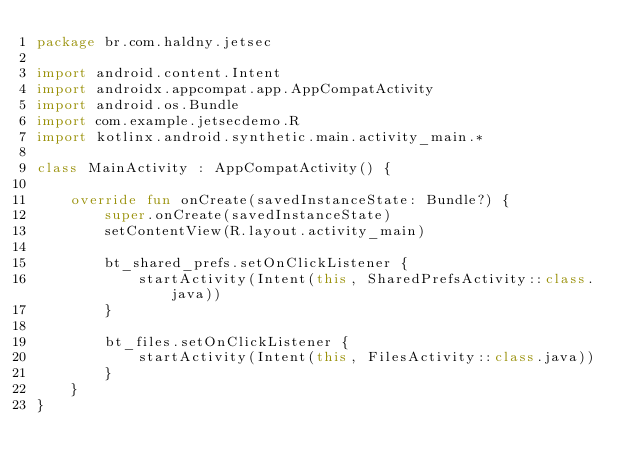Convert code to text. <code><loc_0><loc_0><loc_500><loc_500><_Kotlin_>package br.com.haldny.jetsec

import android.content.Intent
import androidx.appcompat.app.AppCompatActivity
import android.os.Bundle
import com.example.jetsecdemo.R
import kotlinx.android.synthetic.main.activity_main.*

class MainActivity : AppCompatActivity() {

    override fun onCreate(savedInstanceState: Bundle?) {
        super.onCreate(savedInstanceState)
        setContentView(R.layout.activity_main)

        bt_shared_prefs.setOnClickListener {
            startActivity(Intent(this, SharedPrefsActivity::class.java))
        }

        bt_files.setOnClickListener {
            startActivity(Intent(this, FilesActivity::class.java))
        }
    }
}
</code> 